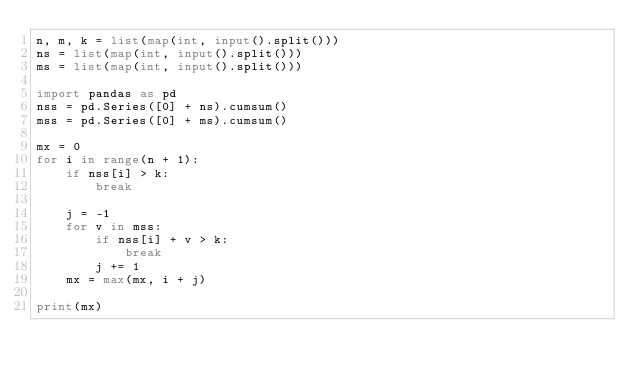<code> <loc_0><loc_0><loc_500><loc_500><_Python_>n, m, k = list(map(int, input().split()))
ns = list(map(int, input().split()))
ms = list(map(int, input().split()))

import pandas as pd
nss = pd.Series([0] + ns).cumsum()
mss = pd.Series([0] + ms).cumsum()

mx = 0
for i in range(n + 1):
    if nss[i] > k:
        break

    j = -1
    for v in mss:
        if nss[i] + v > k:
            break
        j += 1
    mx = max(mx, i + j)

print(mx)</code> 